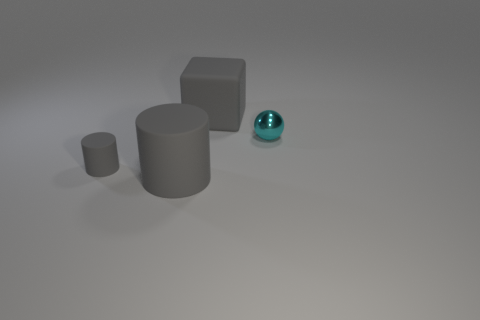Are there any other things that have the same size as the ball?
Provide a succinct answer. Yes. The rubber cube that is the same color as the big rubber cylinder is what size?
Ensure brevity in your answer.  Large. What is the color of the thing that is the same size as the metallic sphere?
Your answer should be very brief. Gray. There is a big matte thing that is the same color as the large rubber cube; what shape is it?
Make the answer very short. Cylinder. What is the color of the big matte thing that is the same shape as the tiny gray thing?
Keep it short and to the point. Gray. Is there anything else that is the same color as the large rubber cylinder?
Give a very brief answer. Yes. What size is the rubber object behind the metal ball?
Keep it short and to the point. Large. There is a big cylinder; does it have the same color as the small object that is right of the large block?
Your response must be concise. No. How many other objects are the same material as the tiny cyan object?
Your answer should be compact. 0. Is the number of blocks greater than the number of small yellow metallic things?
Give a very brief answer. Yes. 